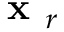Convert formula to latex. <formula><loc_0><loc_0><loc_500><loc_500>x _ { r }</formula> 